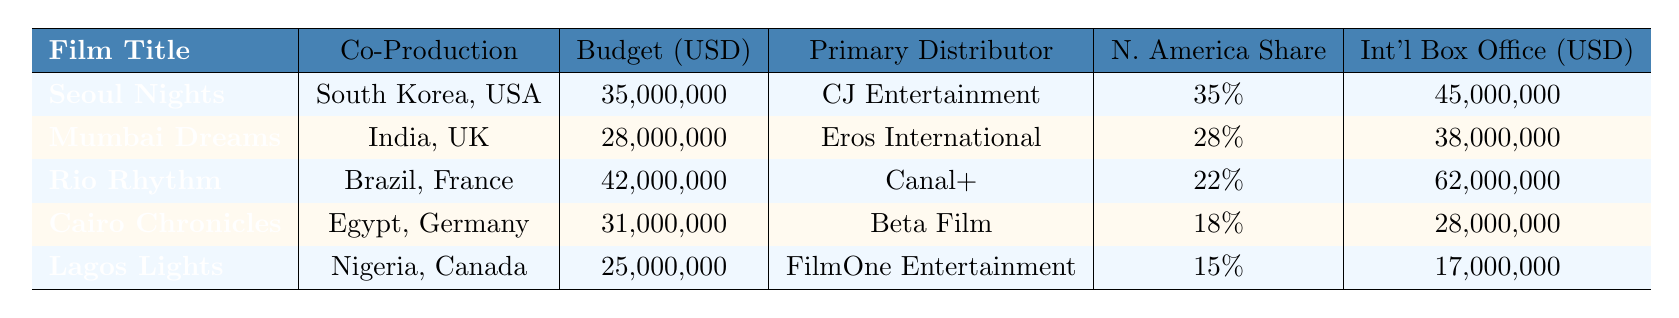What is the production budget for "Rio Rhythm"? The table lists "Rio Rhythm" with a production budget of 42,000,000 USD.
Answer: 42,000,000 USD Which film has the highest international box office revenue? By looking at the international box office figures, "Rio Rhythm" has the highest revenue at 62,000,000 USD.
Answer: "Rio Rhythm" What percentage of revenue does "Cairo Chronicles" share in North America? The North America revenue share for "Cairo Chronicles" is stated as 18% in the table.
Answer: 18% Is the primary distributor for "Seoul Nights" different from that of "Mumbai Dreams"? "Seoul Nights" is distributed by CJ Entertainment, while "Mumbai Dreams" has Eros International as its primary distributor, so they are different.
Answer: Yes What is the total international box office revenue for "Lagos Lights" and "Cairo Chronicles"? The international box office for "Lagos Lights" is 17,000,000 USD and for "Cairo Chronicles" it is 28,000,000 USD. Summing these gives 17,000,000 + 28,000,000 = 45,000,000 USD.
Answer: 45,000,000 USD What is the average North America revenue share for all listed films? The North America shares are 35%, 28%, 22%, 18%, and 15%. The sum is 35 + 28 + 22 + 18 + 15 = 118%. There are 5 films, so the average is 118% / 5 = 23.6%.
Answer: 23.6% Which film has the lowest domestic box office revenue? The domestic box office revenue for "Lagos Lights" is 5,000,000 USD, which is the lowest compared to the others.
Answer: "Lagos Lights" What is the revenue sharing percentage for "Mumbai Dreams" in Europe? The revenue share for "Mumbai Dreams" in Europe is 32%, as stated in the table.
Answer: 32% Which two films are co-produced by countries that are both in the BRICS group? "Rio Rhythm" (Brazil, France) and "Mumbai Dreams" (India, UK) include films from BRICS countries but France and the UK are not part of BRICS. Only "Rio Rhythm" has one BRICS country involved.
Answer: "Rio Rhythm" How many total countries are involved in the theatrical releases for all films combined? The table shows the number of theatrical release countries for each film: 45, 38, 52, 40, and 35. The total is 45 + 38 + 52 + 40 + 35 = 210.
Answer: 210 